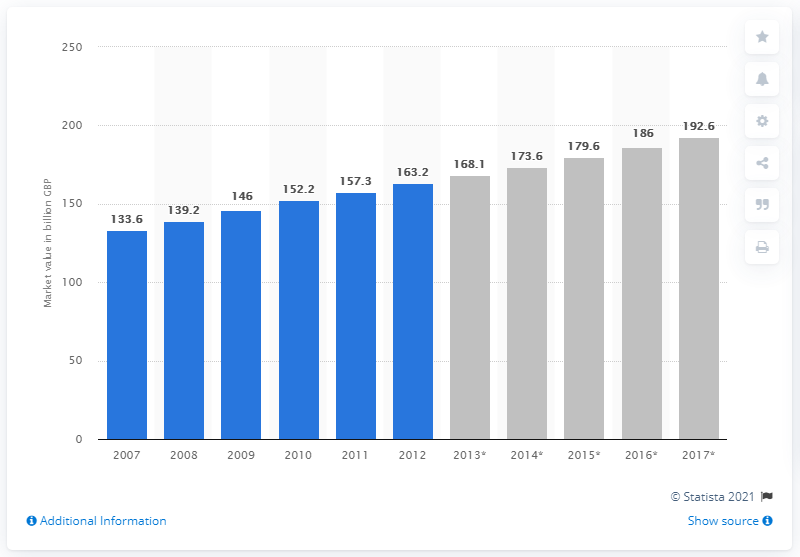Draw attention to some important aspects in this diagram. The grocery market in the United Kingdom was valued at 163.2 billion pounds in 2012. The grocery retail market in the UK had a total annual value in 2007. In 2012, the total value of the UK grocery market was 192.6 billion pounds. 